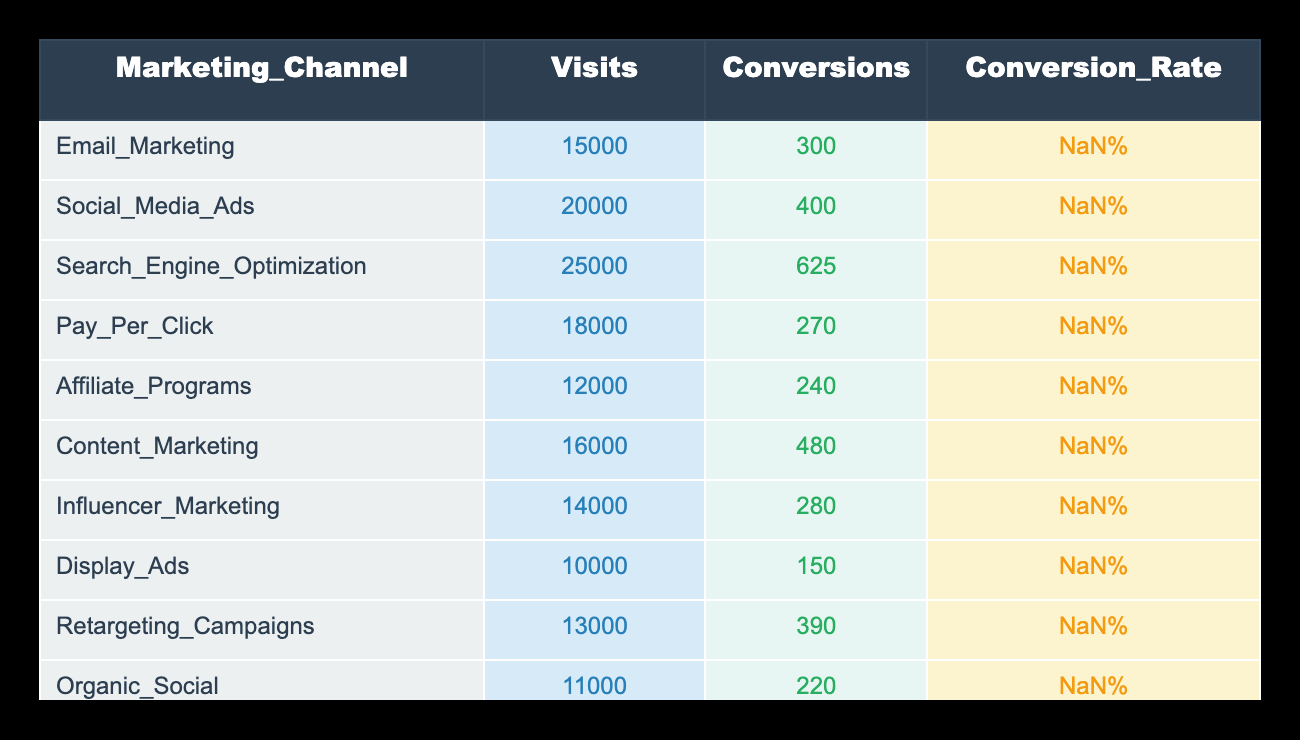What is the conversion rate for Content Marketing? According to the table, the conversion rate for Content Marketing is directly listed in the corresponding row as 3.00%.
Answer: 3.00% Which marketing channel has the highest number of conversions? By looking at the 'Conversions' column, Search Engine Optimization has the highest number of conversions with 625, which is greater than all other channels.
Answer: Search Engine Optimization What is the total number of visits from the top three highest-converting marketing channels? The top three highest-converting channels based on the 'Conversion Rate', which are Content Marketing (16000 visits), Search Engine Optimization (25000 visits), and Retargeting Campaigns (13000 visits), give a total of 16000 + 25000 + 13000 = 54000 visits.
Answer: 54000 Are the conversion rates for Pay Per Click and Display Ads the same? By checking the 'Conversion Rate' column, Pay Per Click shows a conversion rate of 1.50% and Display Ads also has the same conversion rate of 1.50%. Thus, they are the same.
Answer: Yes What is the average conversion rate of all marketing channels listed? To calculate the average conversion rate, sum up all conversion rates: 2.00% + 2.00% + 2.50% + 1.50% + 2.00% + 3.00% + 2.00% + 1.50% + 3.00% + 2.00% = 2.10%. Then divide by the number of channels (10): 21.00% / 10 = 2.10%.
Answer: 2.10% Which marketing channel shows the lowest conversion rate? A glance at the 'Conversion Rate' column reveals that Pay Per Click and Display Ads both have the lowest conversion rate at 1.50%, lower than all other channels.
Answer: Pay Per Click and Display Ads What is the difference in conversion rates between Content Marketing and Affiliate Programs? Content Marketing has a conversion rate of 3.00% while Affiliate Programs has a conversion rate of 2.00%. Thus, the difference is calculated as 3.00% - 2.00% = 1.00%.
Answer: 1.00% Is the conversion rate for Email Marketing higher than that for Social Media Ads? Checking the conversion rates, both Email Marketing and Social Media Ads have the same conversion rate of 2.00%. Thus, the statement is false.
Answer: No Which marketing channel has the fewest visits and what is the conversion rate for that channel? The 'Visits' column indicates that Display Ads has the fewest visits at 10000. Correspondingly, the conversion rate for Display Ads is 1.50%.
Answer: Display Ads, 1.50% 